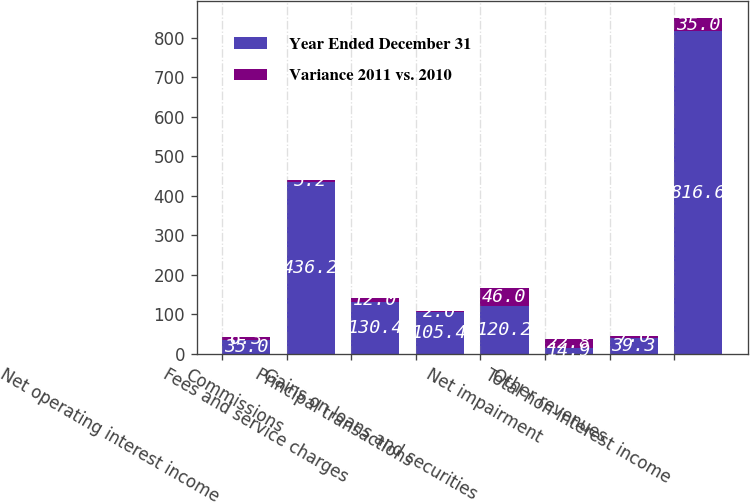<chart> <loc_0><loc_0><loc_500><loc_500><stacked_bar_chart><ecel><fcel>Net operating interest income<fcel>Commissions<fcel>Fees and service charges<fcel>Principal transactions<fcel>Gains on loans and securities<fcel>Net impairment<fcel>Other revenues<fcel>Total non-interest income<nl><fcel>Year Ended December 31<fcel>35<fcel>436.2<fcel>130.4<fcel>105.4<fcel>120.2<fcel>14.9<fcel>39.3<fcel>816.6<nl><fcel>Variance 2011 vs. 2010<fcel>6.3<fcel>5.2<fcel>12<fcel>2<fcel>46<fcel>22.8<fcel>7<fcel>35<nl></chart> 